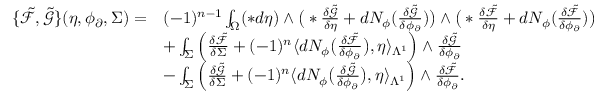<formula> <loc_0><loc_0><loc_500><loc_500>\begin{array} { r l } { \{ \tilde { \mathcal { F } } , \tilde { \mathcal { G } } \} ( \eta , \phi _ { \partial } , \Sigma ) = } & { ( - 1 ) ^ { n - 1 } \int _ { \Omega } ( \ast d \eta ) \wedge \left ( \ast \frac { \delta \tilde { \mathcal { G } } } { \delta \eta } + d N _ { \phi } ( \frac { \delta \tilde { \mathcal { G } } } { \delta \phi _ { \partial } } ) \right ) \wedge \left ( \ast \frac { \delta \tilde { \mathcal { F } } } { \delta \eta } + d N _ { \phi } ( \frac { \delta \tilde { \mathcal { F } } } { \delta \phi _ { \partial } } ) \right ) } \\ & { + \int _ { \Sigma } \left ( \frac { \delta \tilde { \mathcal { F } } } { \delta \Sigma } + ( - 1 ) ^ { n } \langle d N _ { \phi } \left ( \frac { \delta \tilde { \mathcal { F } } } { \delta \phi _ { \partial } } \right ) , \eta \rangle _ { \Lambda ^ { 1 } } \right ) \wedge \frac { \delta \tilde { \mathcal { G } } } { \delta \phi _ { \partial } } } \\ & { - \int _ { \Sigma } \left ( \frac { \delta \tilde { \mathcal { G } } } { \delta \Sigma } + ( - 1 ) ^ { n } \langle d N _ { \phi } \left ( \frac { \delta \tilde { \mathcal { G } } } { \delta \phi _ { \partial } } \right ) , \eta \rangle _ { \Lambda ^ { 1 } } \right ) \wedge \frac { \delta \tilde { \mathcal { F } } } { \delta \phi _ { \partial } } . } \end{array}</formula> 